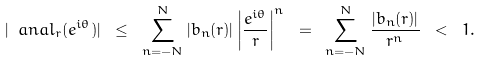<formula> <loc_0><loc_0><loc_500><loc_500>| \ a n a l _ { r } ( e ^ { i \theta } ) | \ \leq \ \sum _ { n = - N } ^ { N } | b _ { n } ( r ) | \left | \frac { e ^ { i \theta } } { r } \right | ^ { n } \ = \ \sum _ { n = - N } ^ { N } \frac { | b _ { n } ( r ) | } { r ^ { n } } \ < \ 1 .</formula> 